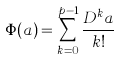Convert formula to latex. <formula><loc_0><loc_0><loc_500><loc_500>\Phi ( a ) = \sum _ { k = 0 } ^ { p - 1 } \frac { D ^ { k } a } { k ! }</formula> 